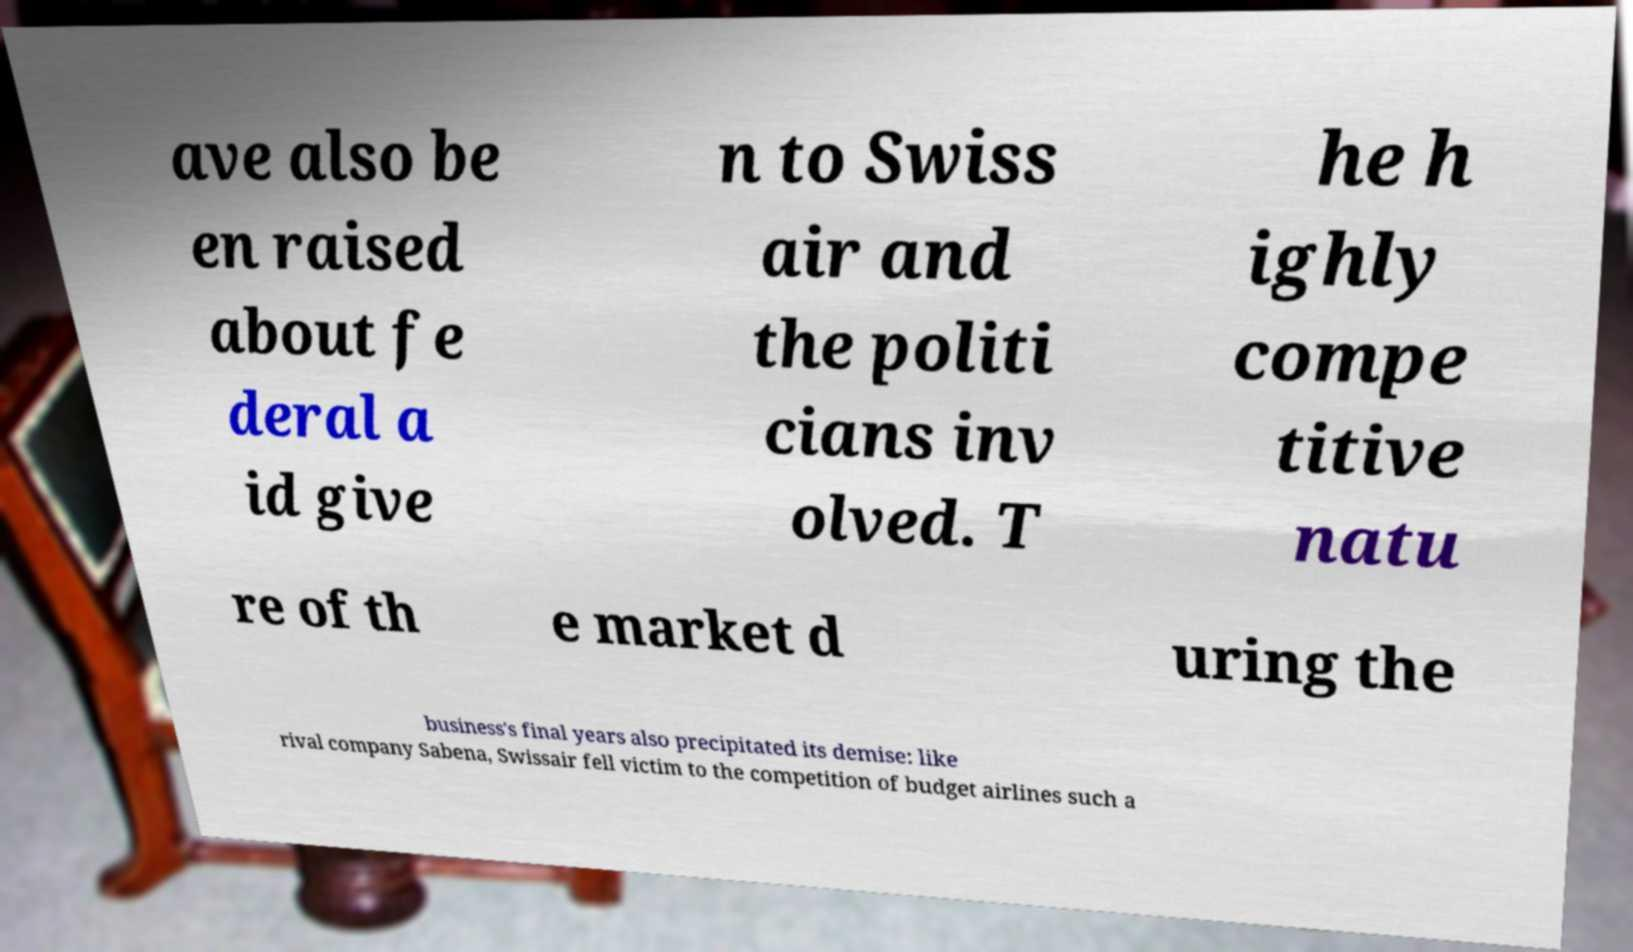Can you read and provide the text displayed in the image?This photo seems to have some interesting text. Can you extract and type it out for me? ave also be en raised about fe deral a id give n to Swiss air and the politi cians inv olved. T he h ighly compe titive natu re of th e market d uring the business's final years also precipitated its demise: like rival company Sabena, Swissair fell victim to the competition of budget airlines such a 